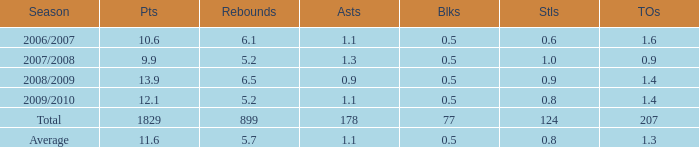How many blocks are there when the rebounds are fewer than 5.2? 0.0. 